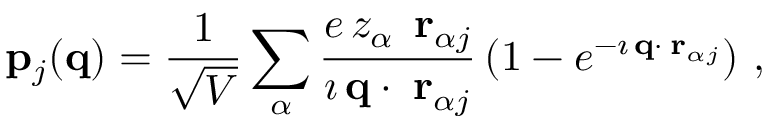<formula> <loc_0><loc_0><loc_500><loc_500>{ p } _ { j } ( { q } ) = \frac { 1 } { \sqrt { V } } \sum _ { \alpha } \frac { e \, z _ { \alpha } \, { \delta r } _ { \alpha j } } { \imath \, { q } \cdot { \delta r } _ { \alpha j } } \left ( 1 - e ^ { - \imath \, { q } \cdot { \delta r } _ { \alpha j } } \right ) \, ,</formula> 